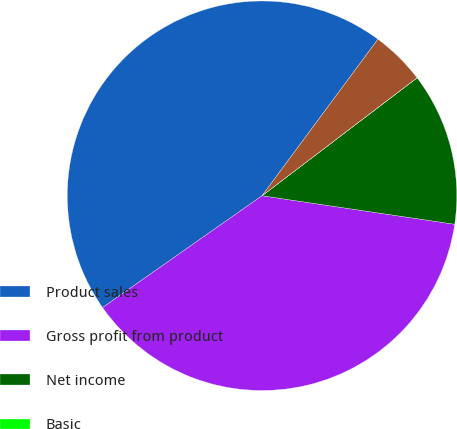Convert chart to OTSL. <chart><loc_0><loc_0><loc_500><loc_500><pie_chart><fcel>Product sales<fcel>Gross profit from product<fcel>Net income<fcel>Basic<fcel>Diluted<nl><fcel>44.88%<fcel>37.93%<fcel>12.69%<fcel>0.01%<fcel>4.5%<nl></chart> 